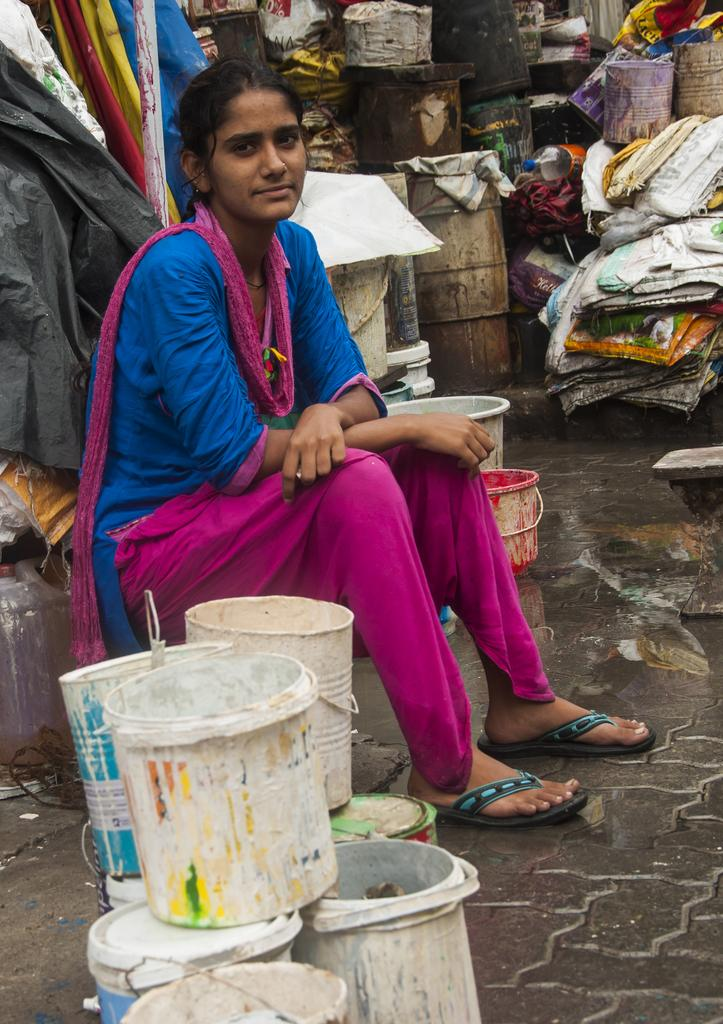Who or what is present in the image? There is a person in the image. What objects can be seen in the image besides the person? There are barrels and containers in the image. What type of vegetable is the boy holding in the image? There is no boy or vegetable present in the image. 